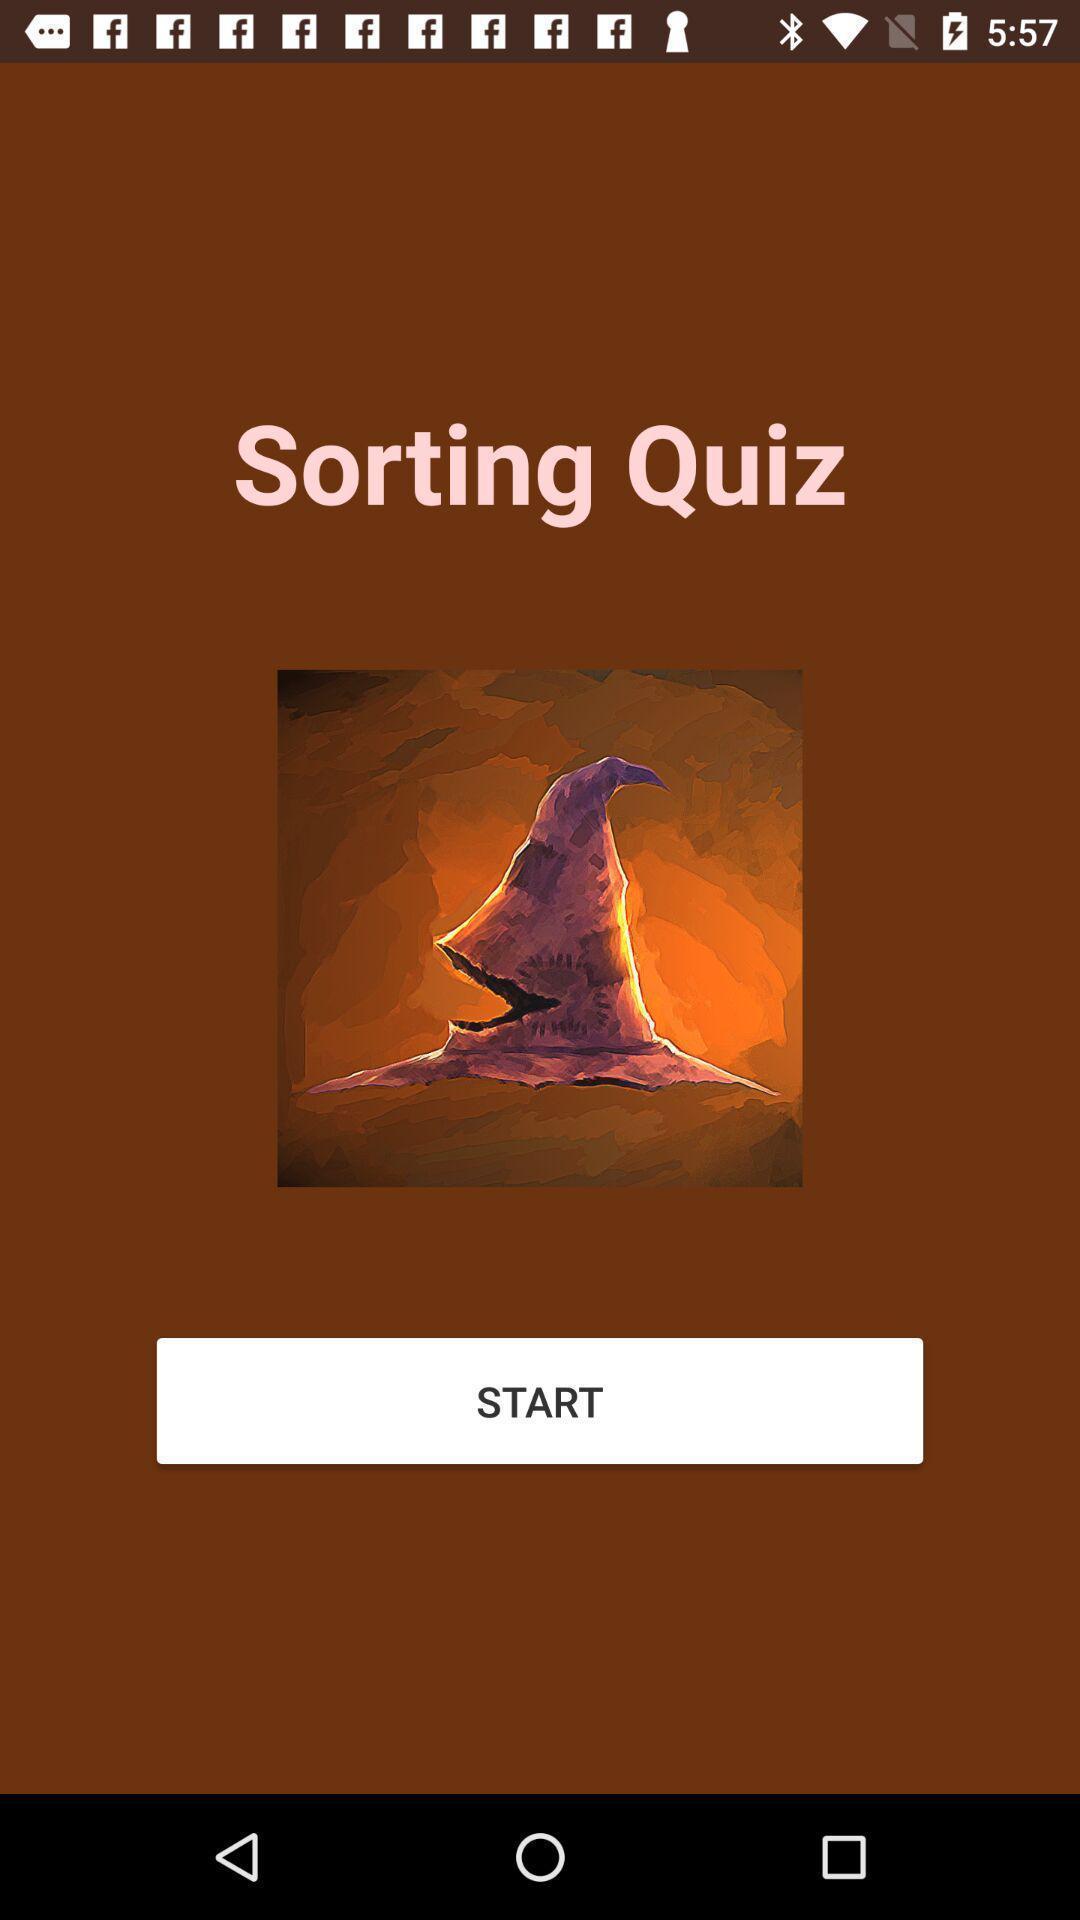Tell me what you see in this picture. Welcome page for a quiz based app. 